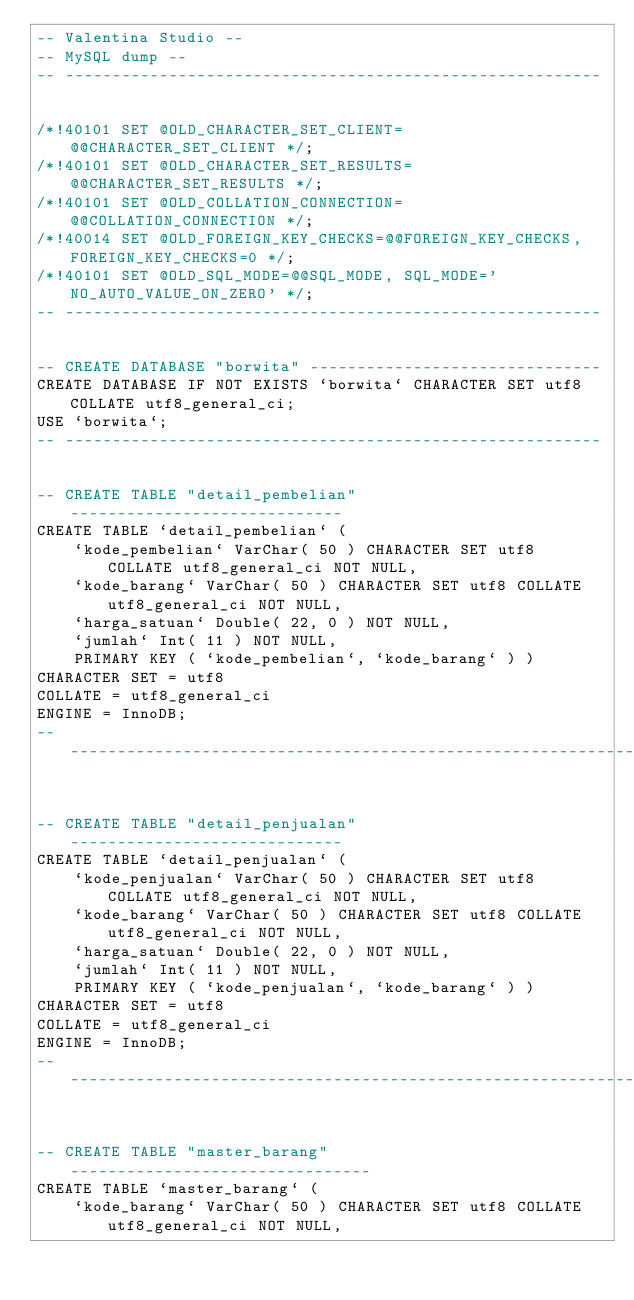<code> <loc_0><loc_0><loc_500><loc_500><_SQL_>-- Valentina Studio --
-- MySQL dump --
-- ---------------------------------------------------------


/*!40101 SET @OLD_CHARACTER_SET_CLIENT=@@CHARACTER_SET_CLIENT */;
/*!40101 SET @OLD_CHARACTER_SET_RESULTS=@@CHARACTER_SET_RESULTS */;
/*!40101 SET @OLD_COLLATION_CONNECTION=@@COLLATION_CONNECTION */;
/*!40014 SET @OLD_FOREIGN_KEY_CHECKS=@@FOREIGN_KEY_CHECKS, FOREIGN_KEY_CHECKS=0 */;
/*!40101 SET @OLD_SQL_MODE=@@SQL_MODE, SQL_MODE='NO_AUTO_VALUE_ON_ZERO' */;
-- ---------------------------------------------------------


-- CREATE DATABASE "borwita" -------------------------------
CREATE DATABASE IF NOT EXISTS `borwita` CHARACTER SET utf8 COLLATE utf8_general_ci;
USE `borwita`;
-- ---------------------------------------------------------


-- CREATE TABLE "detail_pembelian" -----------------------------
CREATE TABLE `detail_pembelian` ( 
	`kode_pembelian` VarChar( 50 ) CHARACTER SET utf8 COLLATE utf8_general_ci NOT NULL,
	`kode_barang` VarChar( 50 ) CHARACTER SET utf8 COLLATE utf8_general_ci NOT NULL,
	`harga_satuan` Double( 22, 0 ) NOT NULL,
	`jumlah` Int( 11 ) NOT NULL,
	PRIMARY KEY ( `kode_pembelian`, `kode_barang` ) )
CHARACTER SET = utf8
COLLATE = utf8_general_ci
ENGINE = InnoDB;
-- -------------------------------------------------------------


-- CREATE TABLE "detail_penjualan" -----------------------------
CREATE TABLE `detail_penjualan` ( 
	`kode_penjualan` VarChar( 50 ) CHARACTER SET utf8 COLLATE utf8_general_ci NOT NULL,
	`kode_barang` VarChar( 50 ) CHARACTER SET utf8 COLLATE utf8_general_ci NOT NULL,
	`harga_satuan` Double( 22, 0 ) NOT NULL,
	`jumlah` Int( 11 ) NOT NULL,
	PRIMARY KEY ( `kode_penjualan`, `kode_barang` ) )
CHARACTER SET = utf8
COLLATE = utf8_general_ci
ENGINE = InnoDB;
-- -------------------------------------------------------------


-- CREATE TABLE "master_barang" --------------------------------
CREATE TABLE `master_barang` ( 
	`kode_barang` VarChar( 50 ) CHARACTER SET utf8 COLLATE utf8_general_ci NOT NULL,</code> 